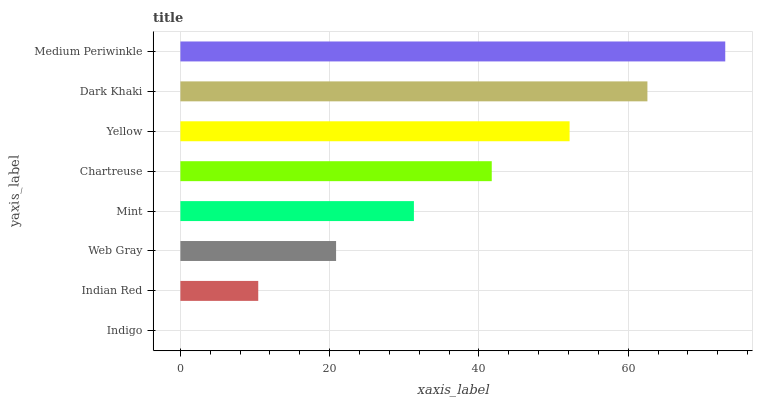Is Indigo the minimum?
Answer yes or no. Yes. Is Medium Periwinkle the maximum?
Answer yes or no. Yes. Is Indian Red the minimum?
Answer yes or no. No. Is Indian Red the maximum?
Answer yes or no. No. Is Indian Red greater than Indigo?
Answer yes or no. Yes. Is Indigo less than Indian Red?
Answer yes or no. Yes. Is Indigo greater than Indian Red?
Answer yes or no. No. Is Indian Red less than Indigo?
Answer yes or no. No. Is Chartreuse the high median?
Answer yes or no. Yes. Is Mint the low median?
Answer yes or no. Yes. Is Medium Periwinkle the high median?
Answer yes or no. No. Is Web Gray the low median?
Answer yes or no. No. 